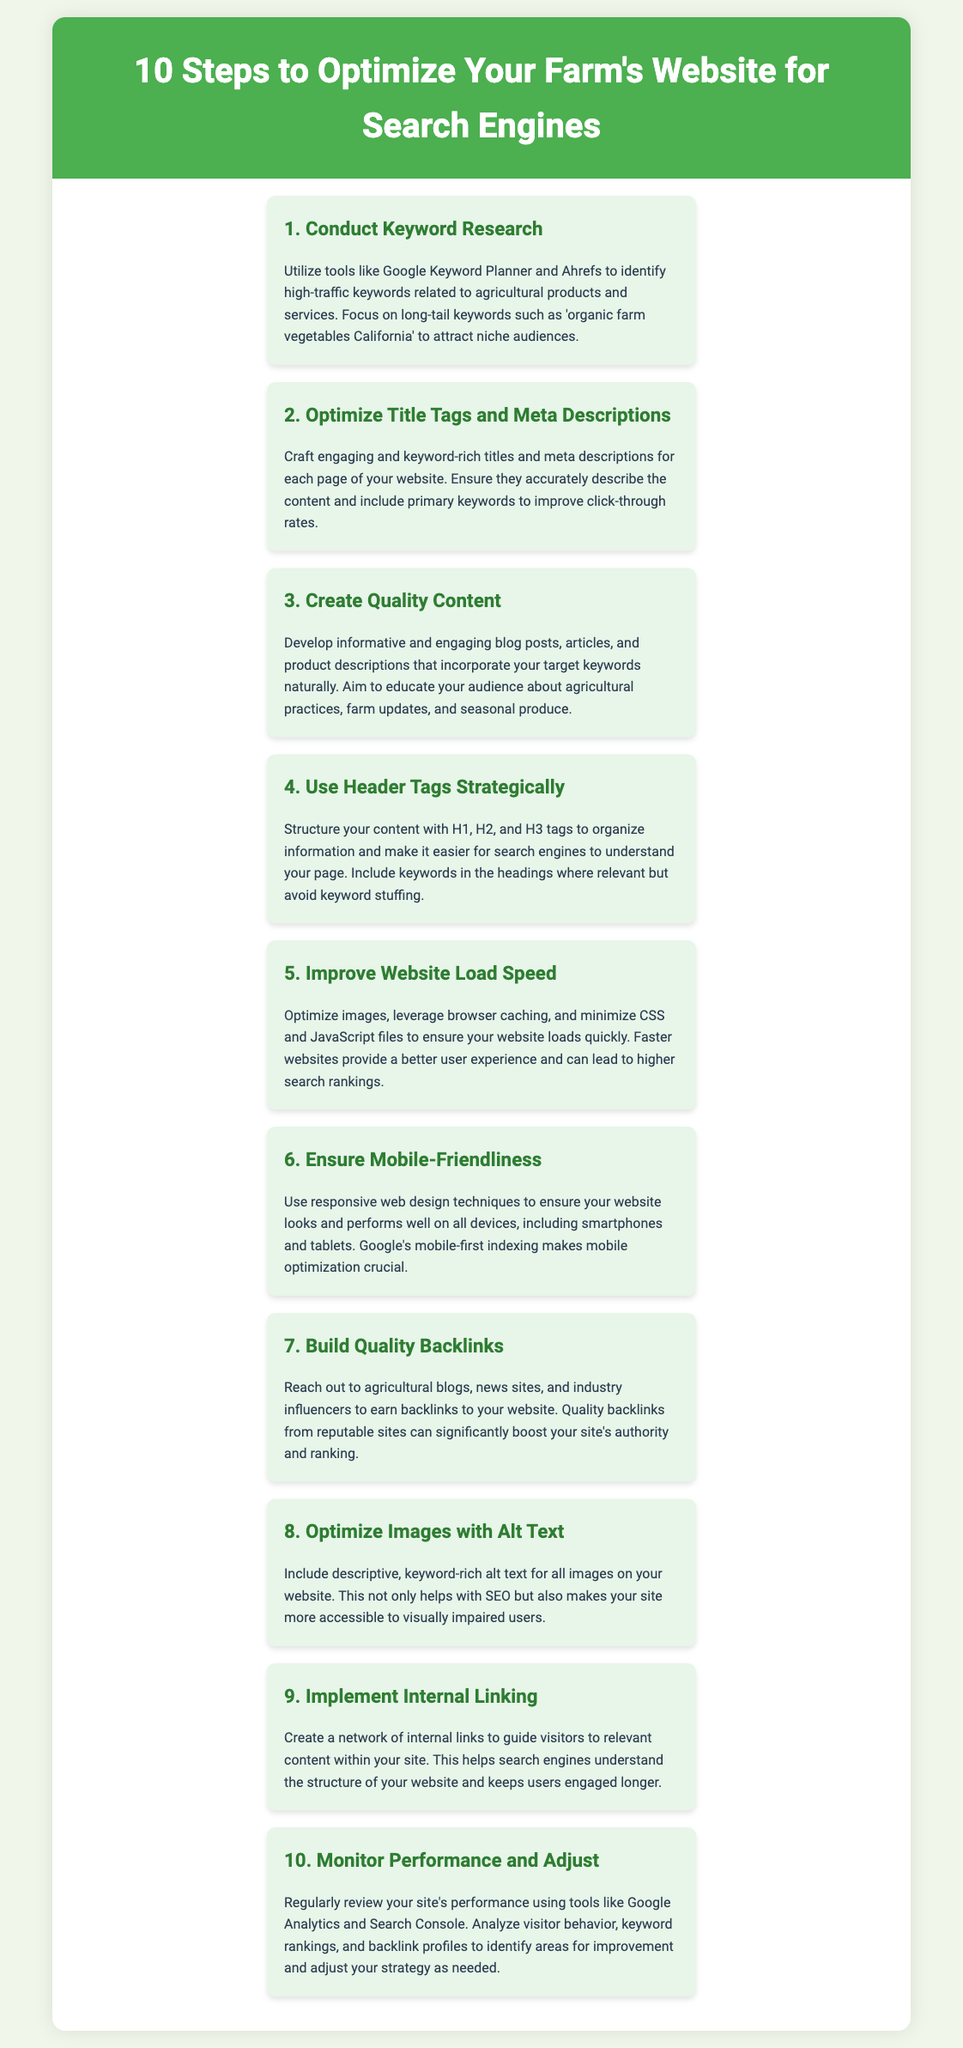what is the first step to optimize a farm's website? The first step mentioned in the document is to conduct keyword research.
Answer: Conduct Keyword Research what does "H1, H2, and H3" refer to? H1, H2, and H3 are types of header tags used strategically to organize information.
Answer: Header tags what is a key tool suggested for keyword research? The document suggests using Google Keyword Planner for keyword research.
Answer: Google Keyword Planner what should alt text for images include? Alt text for images should include descriptive, keyword-rich content.
Answer: Descriptive, keyword-rich how many steps are mentioned in this document? The document lists a total of ten steps to optimize a website.
Answer: Ten steps what is the purpose of internal linking? The purpose of internal linking is to guide visitors to relevant content within the site.
Answer: Guide visitors which type of optimization is crucial according to the mobile-first indexing? Mobile optimization is crucial according to Google's mobile-first indexing.
Answer: Mobile optimization what should be monitored regularly to improve site performance? Regularly monitoring site performance with tools like Google Analytics is recommended.
Answer: Google Analytics how can website load speed be improved? Website load speed can be improved by optimizing images and minimizing CSS and JavaScript files.
Answer: Optimize images what aspect of a website does backlinking improve? Backlinking improves the site's authority and ranking on search engines.
Answer: Authority and ranking 